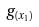Convert formula to latex. <formula><loc_0><loc_0><loc_500><loc_500>g _ { ( x _ { 1 } ) }</formula> 